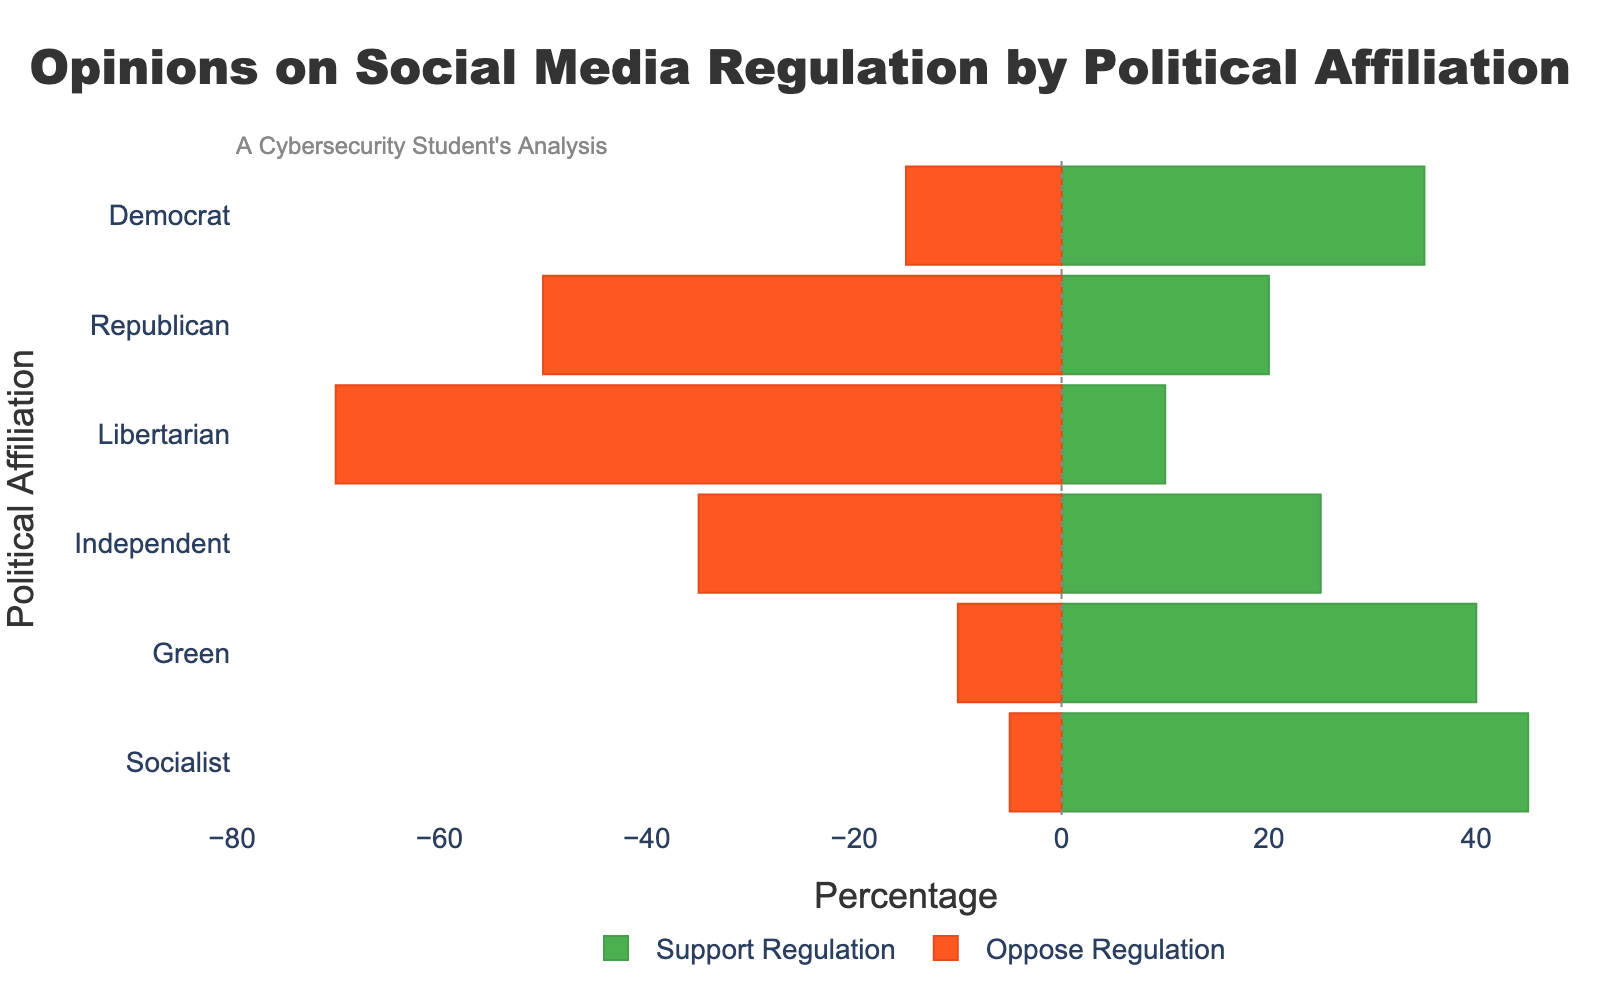How many political affiliations show more support than opposition for social media regulation? To answer this, count the number of affiliations where the green bar (support) extends further to the right than the red bar (oppose) extends to the left.
Answer: 4 Which political affiliation has the largest opposition to social media regulation? Look for the largest red bar (opposition) and identify the corresponding affiliation.
Answer: Libertarian What is the total percentage of support for regulation from Democrat and Socialist? Sum the values for "Support Regulation" for Democrat (35) and Socialist (45).
Answer: 80 Which political affiliation has the closest balance between support and opposition for social media regulation? Identify the affiliation where the lengths of the green (support) and red (oppose) bars are the most equal, meaning their absolute values are closest.
Answer: Independent How much greater is the support for regulation from the Green party compared to the Libertarian party? Subtract the "Support Regulation" value for Libertarian (10) from the value for Green (40).
Answer: 30 Which affiliations have more people opposing than supporting social media regulation? Identify affiliations where the red bar (opposition) extends further to the left than the green bar (support) extends to the right.
Answer: Republican, Libertarian, Independent What is the difference in opposition to regulation between Republicans and Independents? Subtract the "Oppose Regulation" value for Independent (35) from the value for Republican (50).
Answer: 15 Which political affiliation has the smallest support for social media regulation? Look for the smallest green bar (support) and identify the corresponding affiliation.
Answer: Libertarian What is the combined total percentage of opposition to regulation from Independent and Republican? Sum the values for "Oppose Regulation" for Independent (35) and Republican (50).
Answer: 85 What is the difference between the highest support for regulation and the highest opposition to regulation? Identify the highest "Support Regulation" value (Socialist at 45) and the highest "Oppose Regulation" value (Libertarian at 70), then subtract the support from the opposition.
Answer: 25 